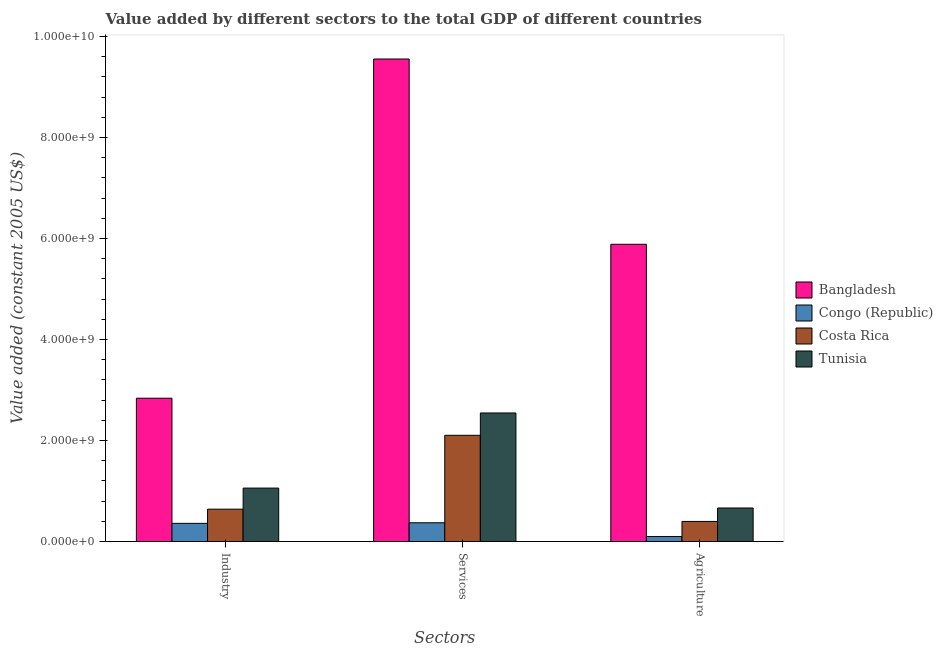How many different coloured bars are there?
Ensure brevity in your answer.  4. How many groups of bars are there?
Ensure brevity in your answer.  3. Are the number of bars on each tick of the X-axis equal?
Ensure brevity in your answer.  Yes. How many bars are there on the 2nd tick from the left?
Provide a succinct answer. 4. What is the label of the 1st group of bars from the left?
Make the answer very short. Industry. What is the value added by industrial sector in Bangladesh?
Provide a short and direct response. 2.84e+09. Across all countries, what is the maximum value added by agricultural sector?
Offer a terse response. 5.89e+09. Across all countries, what is the minimum value added by agricultural sector?
Offer a terse response. 1.01e+08. In which country was the value added by industrial sector maximum?
Your answer should be very brief. Bangladesh. In which country was the value added by agricultural sector minimum?
Offer a terse response. Congo (Republic). What is the total value added by agricultural sector in the graph?
Make the answer very short. 7.05e+09. What is the difference between the value added by agricultural sector in Bangladesh and that in Congo (Republic)?
Your response must be concise. 5.79e+09. What is the difference between the value added by services in Bangladesh and the value added by agricultural sector in Costa Rica?
Your response must be concise. 9.16e+09. What is the average value added by services per country?
Keep it short and to the point. 3.64e+09. What is the difference between the value added by industrial sector and value added by agricultural sector in Bangladesh?
Ensure brevity in your answer.  -3.05e+09. What is the ratio of the value added by services in Congo (Republic) to that in Costa Rica?
Your response must be concise. 0.18. What is the difference between the highest and the second highest value added by agricultural sector?
Your response must be concise. 5.22e+09. What is the difference between the highest and the lowest value added by agricultural sector?
Your answer should be very brief. 5.79e+09. In how many countries, is the value added by industrial sector greater than the average value added by industrial sector taken over all countries?
Make the answer very short. 1. Is the sum of the value added by agricultural sector in Congo (Republic) and Tunisia greater than the maximum value added by industrial sector across all countries?
Offer a terse response. No. What does the 3rd bar from the left in Industry represents?
Your answer should be compact. Costa Rica. What does the 3rd bar from the right in Services represents?
Your answer should be compact. Congo (Republic). Are all the bars in the graph horizontal?
Your answer should be compact. No. Are the values on the major ticks of Y-axis written in scientific E-notation?
Ensure brevity in your answer.  Yes. Does the graph contain any zero values?
Provide a short and direct response. No. Where does the legend appear in the graph?
Offer a terse response. Center right. What is the title of the graph?
Provide a succinct answer. Value added by different sectors to the total GDP of different countries. What is the label or title of the X-axis?
Give a very brief answer. Sectors. What is the label or title of the Y-axis?
Offer a very short reply. Value added (constant 2005 US$). What is the Value added (constant 2005 US$) in Bangladesh in Industry?
Keep it short and to the point. 2.84e+09. What is the Value added (constant 2005 US$) of Congo (Republic) in Industry?
Your answer should be compact. 3.61e+08. What is the Value added (constant 2005 US$) of Costa Rica in Industry?
Provide a short and direct response. 6.41e+08. What is the Value added (constant 2005 US$) in Tunisia in Industry?
Provide a short and direct response. 1.06e+09. What is the Value added (constant 2005 US$) of Bangladesh in Services?
Your answer should be very brief. 9.56e+09. What is the Value added (constant 2005 US$) of Congo (Republic) in Services?
Make the answer very short. 3.72e+08. What is the Value added (constant 2005 US$) of Costa Rica in Services?
Offer a terse response. 2.10e+09. What is the Value added (constant 2005 US$) of Tunisia in Services?
Provide a short and direct response. 2.55e+09. What is the Value added (constant 2005 US$) in Bangladesh in Agriculture?
Your answer should be very brief. 5.89e+09. What is the Value added (constant 2005 US$) in Congo (Republic) in Agriculture?
Provide a succinct answer. 1.01e+08. What is the Value added (constant 2005 US$) in Costa Rica in Agriculture?
Provide a succinct answer. 3.99e+08. What is the Value added (constant 2005 US$) in Tunisia in Agriculture?
Keep it short and to the point. 6.65e+08. Across all Sectors, what is the maximum Value added (constant 2005 US$) of Bangladesh?
Your response must be concise. 9.56e+09. Across all Sectors, what is the maximum Value added (constant 2005 US$) in Congo (Republic)?
Give a very brief answer. 3.72e+08. Across all Sectors, what is the maximum Value added (constant 2005 US$) of Costa Rica?
Provide a succinct answer. 2.10e+09. Across all Sectors, what is the maximum Value added (constant 2005 US$) in Tunisia?
Your answer should be compact. 2.55e+09. Across all Sectors, what is the minimum Value added (constant 2005 US$) in Bangladesh?
Your answer should be very brief. 2.84e+09. Across all Sectors, what is the minimum Value added (constant 2005 US$) in Congo (Republic)?
Your answer should be compact. 1.01e+08. Across all Sectors, what is the minimum Value added (constant 2005 US$) in Costa Rica?
Your answer should be very brief. 3.99e+08. Across all Sectors, what is the minimum Value added (constant 2005 US$) in Tunisia?
Offer a terse response. 6.65e+08. What is the total Value added (constant 2005 US$) of Bangladesh in the graph?
Offer a very short reply. 1.83e+1. What is the total Value added (constant 2005 US$) in Congo (Republic) in the graph?
Your answer should be compact. 8.33e+08. What is the total Value added (constant 2005 US$) of Costa Rica in the graph?
Give a very brief answer. 3.14e+09. What is the total Value added (constant 2005 US$) of Tunisia in the graph?
Your answer should be very brief. 4.27e+09. What is the difference between the Value added (constant 2005 US$) in Bangladesh in Industry and that in Services?
Ensure brevity in your answer.  -6.72e+09. What is the difference between the Value added (constant 2005 US$) of Congo (Republic) in Industry and that in Services?
Give a very brief answer. -1.14e+07. What is the difference between the Value added (constant 2005 US$) in Costa Rica in Industry and that in Services?
Provide a short and direct response. -1.46e+09. What is the difference between the Value added (constant 2005 US$) in Tunisia in Industry and that in Services?
Make the answer very short. -1.49e+09. What is the difference between the Value added (constant 2005 US$) of Bangladesh in Industry and that in Agriculture?
Offer a terse response. -3.05e+09. What is the difference between the Value added (constant 2005 US$) in Congo (Republic) in Industry and that in Agriculture?
Give a very brief answer. 2.60e+08. What is the difference between the Value added (constant 2005 US$) of Costa Rica in Industry and that in Agriculture?
Provide a succinct answer. 2.43e+08. What is the difference between the Value added (constant 2005 US$) in Tunisia in Industry and that in Agriculture?
Your answer should be very brief. 3.94e+08. What is the difference between the Value added (constant 2005 US$) of Bangladesh in Services and that in Agriculture?
Give a very brief answer. 3.67e+09. What is the difference between the Value added (constant 2005 US$) of Congo (Republic) in Services and that in Agriculture?
Provide a short and direct response. 2.72e+08. What is the difference between the Value added (constant 2005 US$) in Costa Rica in Services and that in Agriculture?
Ensure brevity in your answer.  1.71e+09. What is the difference between the Value added (constant 2005 US$) in Tunisia in Services and that in Agriculture?
Your answer should be compact. 1.88e+09. What is the difference between the Value added (constant 2005 US$) of Bangladesh in Industry and the Value added (constant 2005 US$) of Congo (Republic) in Services?
Ensure brevity in your answer.  2.47e+09. What is the difference between the Value added (constant 2005 US$) of Bangladesh in Industry and the Value added (constant 2005 US$) of Costa Rica in Services?
Provide a succinct answer. 7.34e+08. What is the difference between the Value added (constant 2005 US$) in Bangladesh in Industry and the Value added (constant 2005 US$) in Tunisia in Services?
Provide a succinct answer. 2.92e+08. What is the difference between the Value added (constant 2005 US$) of Congo (Republic) in Industry and the Value added (constant 2005 US$) of Costa Rica in Services?
Your answer should be very brief. -1.74e+09. What is the difference between the Value added (constant 2005 US$) of Congo (Republic) in Industry and the Value added (constant 2005 US$) of Tunisia in Services?
Ensure brevity in your answer.  -2.19e+09. What is the difference between the Value added (constant 2005 US$) in Costa Rica in Industry and the Value added (constant 2005 US$) in Tunisia in Services?
Keep it short and to the point. -1.90e+09. What is the difference between the Value added (constant 2005 US$) in Bangladesh in Industry and the Value added (constant 2005 US$) in Congo (Republic) in Agriculture?
Give a very brief answer. 2.74e+09. What is the difference between the Value added (constant 2005 US$) in Bangladesh in Industry and the Value added (constant 2005 US$) in Costa Rica in Agriculture?
Your answer should be compact. 2.44e+09. What is the difference between the Value added (constant 2005 US$) in Bangladesh in Industry and the Value added (constant 2005 US$) in Tunisia in Agriculture?
Offer a terse response. 2.17e+09. What is the difference between the Value added (constant 2005 US$) in Congo (Republic) in Industry and the Value added (constant 2005 US$) in Costa Rica in Agriculture?
Your answer should be compact. -3.79e+07. What is the difference between the Value added (constant 2005 US$) of Congo (Republic) in Industry and the Value added (constant 2005 US$) of Tunisia in Agriculture?
Provide a succinct answer. -3.04e+08. What is the difference between the Value added (constant 2005 US$) of Costa Rica in Industry and the Value added (constant 2005 US$) of Tunisia in Agriculture?
Your answer should be compact. -2.35e+07. What is the difference between the Value added (constant 2005 US$) in Bangladesh in Services and the Value added (constant 2005 US$) in Congo (Republic) in Agriculture?
Your answer should be very brief. 9.46e+09. What is the difference between the Value added (constant 2005 US$) in Bangladesh in Services and the Value added (constant 2005 US$) in Costa Rica in Agriculture?
Your answer should be compact. 9.16e+09. What is the difference between the Value added (constant 2005 US$) in Bangladesh in Services and the Value added (constant 2005 US$) in Tunisia in Agriculture?
Keep it short and to the point. 8.89e+09. What is the difference between the Value added (constant 2005 US$) of Congo (Republic) in Services and the Value added (constant 2005 US$) of Costa Rica in Agriculture?
Offer a very short reply. -2.65e+07. What is the difference between the Value added (constant 2005 US$) of Congo (Republic) in Services and the Value added (constant 2005 US$) of Tunisia in Agriculture?
Offer a very short reply. -2.93e+08. What is the difference between the Value added (constant 2005 US$) of Costa Rica in Services and the Value added (constant 2005 US$) of Tunisia in Agriculture?
Provide a short and direct response. 1.44e+09. What is the average Value added (constant 2005 US$) in Bangladesh per Sectors?
Give a very brief answer. 6.09e+09. What is the average Value added (constant 2005 US$) in Congo (Republic) per Sectors?
Provide a short and direct response. 2.78e+08. What is the average Value added (constant 2005 US$) of Costa Rica per Sectors?
Your response must be concise. 1.05e+09. What is the average Value added (constant 2005 US$) of Tunisia per Sectors?
Your answer should be compact. 1.42e+09. What is the difference between the Value added (constant 2005 US$) of Bangladesh and Value added (constant 2005 US$) of Congo (Republic) in Industry?
Offer a terse response. 2.48e+09. What is the difference between the Value added (constant 2005 US$) in Bangladesh and Value added (constant 2005 US$) in Costa Rica in Industry?
Make the answer very short. 2.20e+09. What is the difference between the Value added (constant 2005 US$) in Bangladesh and Value added (constant 2005 US$) in Tunisia in Industry?
Provide a succinct answer. 1.78e+09. What is the difference between the Value added (constant 2005 US$) in Congo (Republic) and Value added (constant 2005 US$) in Costa Rica in Industry?
Ensure brevity in your answer.  -2.81e+08. What is the difference between the Value added (constant 2005 US$) of Congo (Republic) and Value added (constant 2005 US$) of Tunisia in Industry?
Offer a very short reply. -6.98e+08. What is the difference between the Value added (constant 2005 US$) of Costa Rica and Value added (constant 2005 US$) of Tunisia in Industry?
Offer a terse response. -4.18e+08. What is the difference between the Value added (constant 2005 US$) of Bangladesh and Value added (constant 2005 US$) of Congo (Republic) in Services?
Make the answer very short. 9.18e+09. What is the difference between the Value added (constant 2005 US$) of Bangladesh and Value added (constant 2005 US$) of Costa Rica in Services?
Give a very brief answer. 7.45e+09. What is the difference between the Value added (constant 2005 US$) in Bangladesh and Value added (constant 2005 US$) in Tunisia in Services?
Ensure brevity in your answer.  7.01e+09. What is the difference between the Value added (constant 2005 US$) of Congo (Republic) and Value added (constant 2005 US$) of Costa Rica in Services?
Give a very brief answer. -1.73e+09. What is the difference between the Value added (constant 2005 US$) of Congo (Republic) and Value added (constant 2005 US$) of Tunisia in Services?
Offer a terse response. -2.17e+09. What is the difference between the Value added (constant 2005 US$) in Costa Rica and Value added (constant 2005 US$) in Tunisia in Services?
Offer a terse response. -4.42e+08. What is the difference between the Value added (constant 2005 US$) in Bangladesh and Value added (constant 2005 US$) in Congo (Republic) in Agriculture?
Make the answer very short. 5.79e+09. What is the difference between the Value added (constant 2005 US$) of Bangladesh and Value added (constant 2005 US$) of Costa Rica in Agriculture?
Keep it short and to the point. 5.49e+09. What is the difference between the Value added (constant 2005 US$) of Bangladesh and Value added (constant 2005 US$) of Tunisia in Agriculture?
Provide a short and direct response. 5.22e+09. What is the difference between the Value added (constant 2005 US$) in Congo (Republic) and Value added (constant 2005 US$) in Costa Rica in Agriculture?
Offer a terse response. -2.98e+08. What is the difference between the Value added (constant 2005 US$) of Congo (Republic) and Value added (constant 2005 US$) of Tunisia in Agriculture?
Keep it short and to the point. -5.64e+08. What is the difference between the Value added (constant 2005 US$) in Costa Rica and Value added (constant 2005 US$) in Tunisia in Agriculture?
Give a very brief answer. -2.66e+08. What is the ratio of the Value added (constant 2005 US$) of Bangladesh in Industry to that in Services?
Provide a succinct answer. 0.3. What is the ratio of the Value added (constant 2005 US$) in Congo (Republic) in Industry to that in Services?
Provide a short and direct response. 0.97. What is the ratio of the Value added (constant 2005 US$) of Costa Rica in Industry to that in Services?
Give a very brief answer. 0.3. What is the ratio of the Value added (constant 2005 US$) in Tunisia in Industry to that in Services?
Offer a very short reply. 0.42. What is the ratio of the Value added (constant 2005 US$) of Bangladesh in Industry to that in Agriculture?
Keep it short and to the point. 0.48. What is the ratio of the Value added (constant 2005 US$) of Congo (Republic) in Industry to that in Agriculture?
Offer a terse response. 3.59. What is the ratio of the Value added (constant 2005 US$) of Costa Rica in Industry to that in Agriculture?
Make the answer very short. 1.61. What is the ratio of the Value added (constant 2005 US$) of Tunisia in Industry to that in Agriculture?
Provide a succinct answer. 1.59. What is the ratio of the Value added (constant 2005 US$) in Bangladesh in Services to that in Agriculture?
Keep it short and to the point. 1.62. What is the ratio of the Value added (constant 2005 US$) of Congo (Republic) in Services to that in Agriculture?
Provide a short and direct response. 3.7. What is the ratio of the Value added (constant 2005 US$) in Costa Rica in Services to that in Agriculture?
Keep it short and to the point. 5.28. What is the ratio of the Value added (constant 2005 US$) in Tunisia in Services to that in Agriculture?
Provide a short and direct response. 3.83. What is the difference between the highest and the second highest Value added (constant 2005 US$) of Bangladesh?
Your answer should be very brief. 3.67e+09. What is the difference between the highest and the second highest Value added (constant 2005 US$) of Congo (Republic)?
Ensure brevity in your answer.  1.14e+07. What is the difference between the highest and the second highest Value added (constant 2005 US$) in Costa Rica?
Offer a very short reply. 1.46e+09. What is the difference between the highest and the second highest Value added (constant 2005 US$) in Tunisia?
Your answer should be compact. 1.49e+09. What is the difference between the highest and the lowest Value added (constant 2005 US$) of Bangladesh?
Offer a very short reply. 6.72e+09. What is the difference between the highest and the lowest Value added (constant 2005 US$) in Congo (Republic)?
Offer a very short reply. 2.72e+08. What is the difference between the highest and the lowest Value added (constant 2005 US$) of Costa Rica?
Offer a very short reply. 1.71e+09. What is the difference between the highest and the lowest Value added (constant 2005 US$) in Tunisia?
Offer a very short reply. 1.88e+09. 